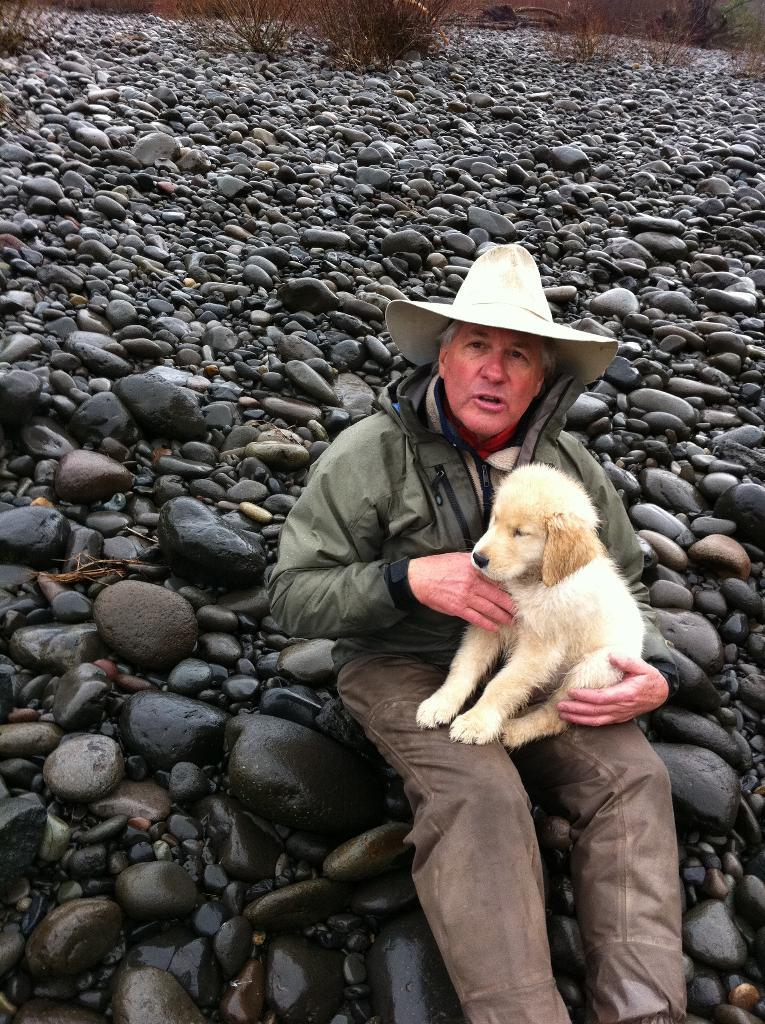What is the person sitting on in the image? The person is sitting on black stones. What is the person holding in the image? The person is holding a dog in his hand. What can be seen behind the person in the image? There are black stones behind the person. Reasoning: Let' Let's think step by step in order to produce the conversation. We start by identifying the main subject in the image, which is the person. Then, we describe what the person is doing, which is sitting on black stones and holding a dog. Finally, we mention the background of the image, which consists of more black stones. Each question is designed to elicit a specific detail about the image that is known from the provided facts. Absurd Question/Answer: What type of copy is the person making of the territory in the image? There is no mention of copying or territory in the image; the person is simply sitting on black stones and holding a dog. 